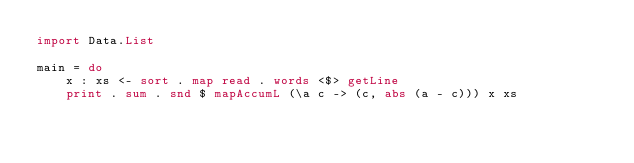<code> <loc_0><loc_0><loc_500><loc_500><_Haskell_>import Data.List

main = do
    x : xs <- sort . map read . words <$> getLine
    print . sum . snd $ mapAccumL (\a c -> (c, abs (a - c))) x xs
</code> 